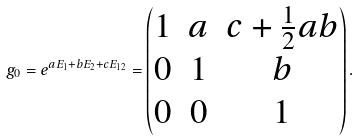<formula> <loc_0><loc_0><loc_500><loc_500>g _ { 0 } = e ^ { a E _ { 1 } + b E _ { 2 } + c E _ { 1 2 } } = \begin{pmatrix} 1 & a & c + \frac { 1 } { 2 } a b \\ 0 & 1 & b \\ 0 & 0 & 1 \end{pmatrix} .</formula> 